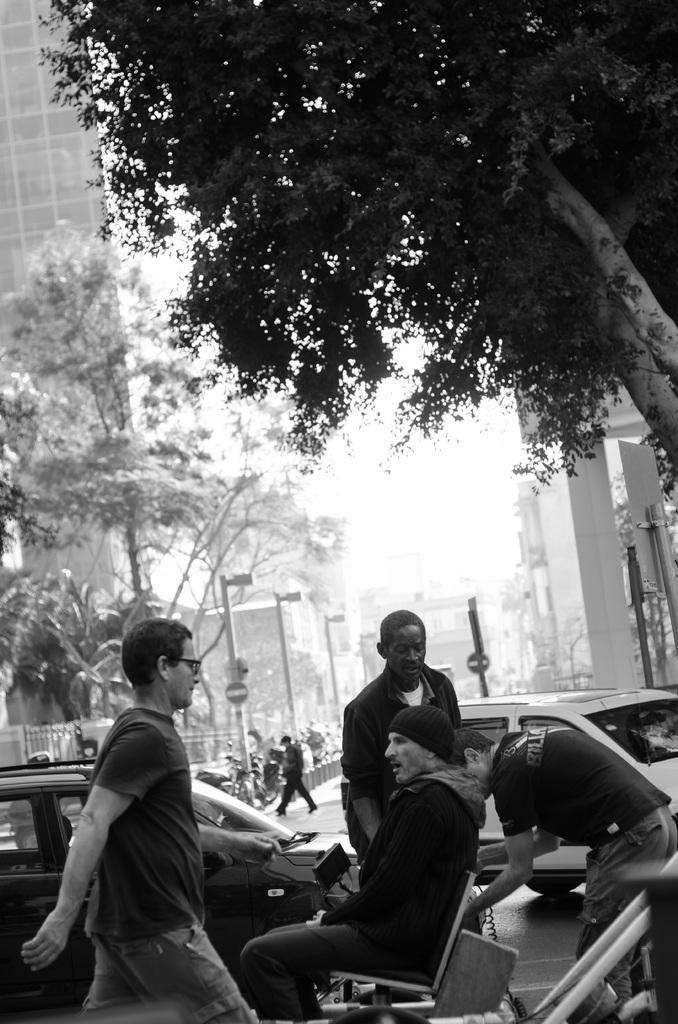Can you describe this image briefly? In this black and white picture there is a person sitting on the chair. Few persons are walking on the pavement. Few vehicles are on the road. A person is crossing the road. There are few poles, behind there are few vehicles. Left side there is a fence. Behind there are few trees. Background there are few buildings. Right side there is a tree. Few boards are attached to the poles. 